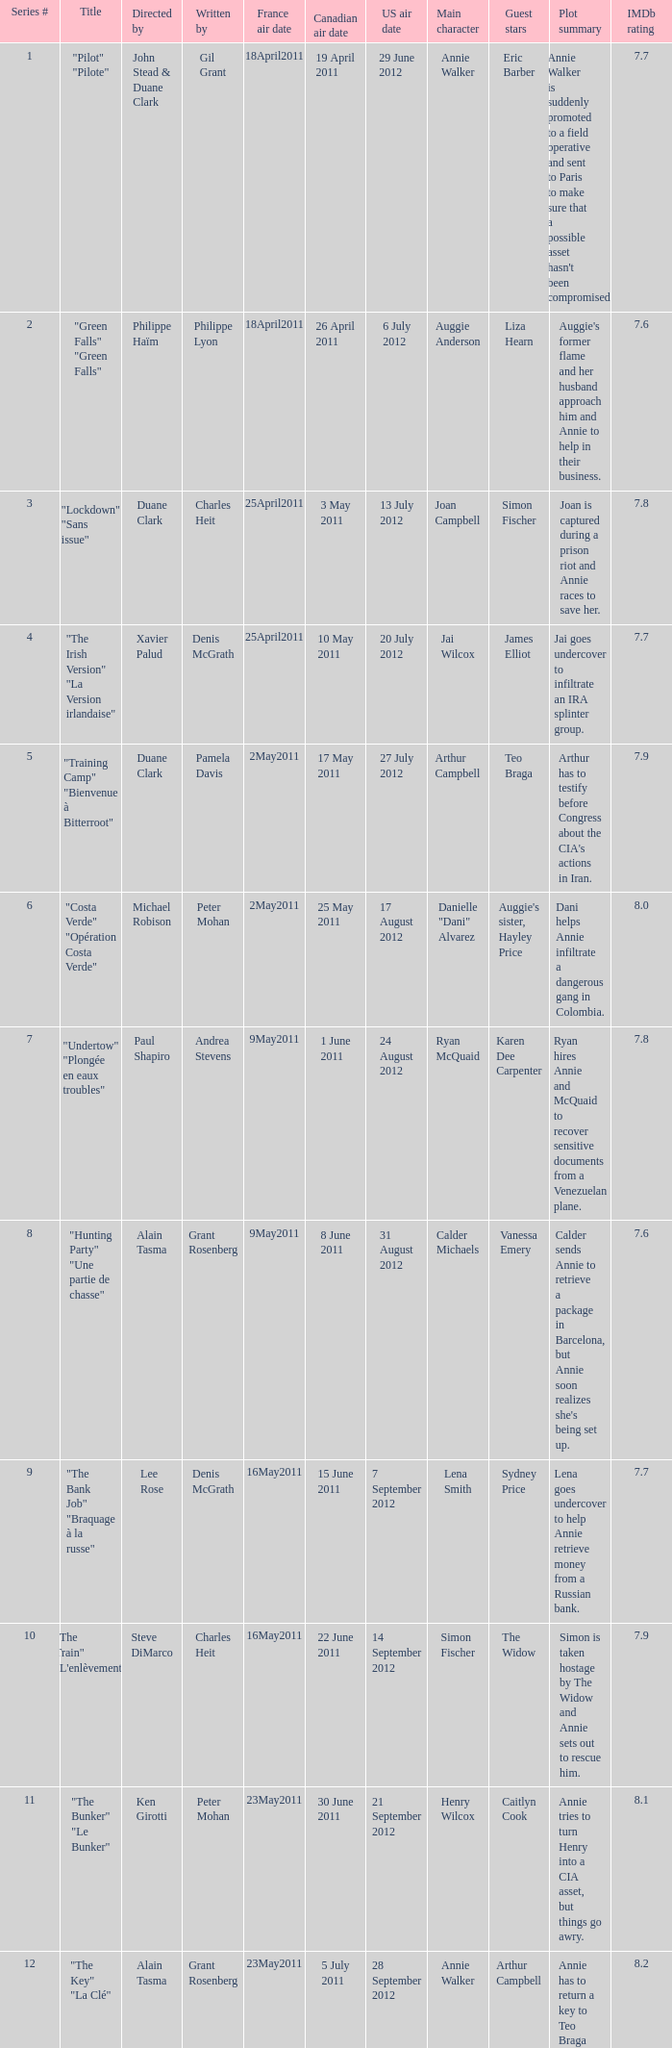What is the canadian air date when the US air date is 24 august 2012? 1 June 2011. 